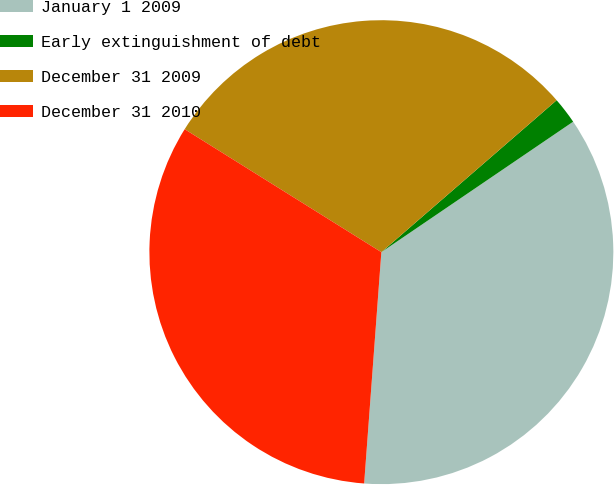<chart> <loc_0><loc_0><loc_500><loc_500><pie_chart><fcel>January 1 2009<fcel>Early extinguishment of debt<fcel>December 31 2009<fcel>December 31 2010<nl><fcel>35.69%<fcel>1.86%<fcel>29.74%<fcel>32.71%<nl></chart> 